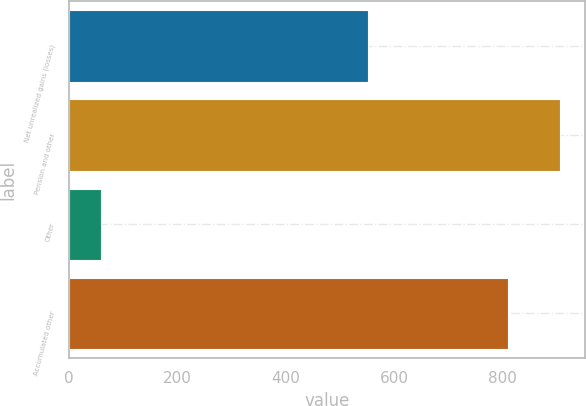<chart> <loc_0><loc_0><loc_500><loc_500><bar_chart><fcel>Net unrealized gains (losses)<fcel>Pension and other<fcel>Other<fcel>Accumulated other<nl><fcel>552<fcel>906.3<fcel>59<fcel>810<nl></chart> 